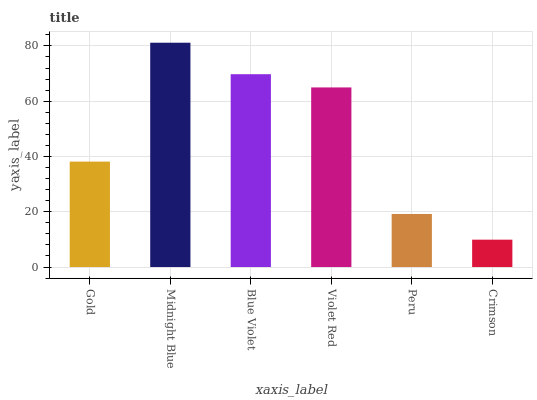Is Crimson the minimum?
Answer yes or no. Yes. Is Midnight Blue the maximum?
Answer yes or no. Yes. Is Blue Violet the minimum?
Answer yes or no. No. Is Blue Violet the maximum?
Answer yes or no. No. Is Midnight Blue greater than Blue Violet?
Answer yes or no. Yes. Is Blue Violet less than Midnight Blue?
Answer yes or no. Yes. Is Blue Violet greater than Midnight Blue?
Answer yes or no. No. Is Midnight Blue less than Blue Violet?
Answer yes or no. No. Is Violet Red the high median?
Answer yes or no. Yes. Is Gold the low median?
Answer yes or no. Yes. Is Peru the high median?
Answer yes or no. No. Is Midnight Blue the low median?
Answer yes or no. No. 